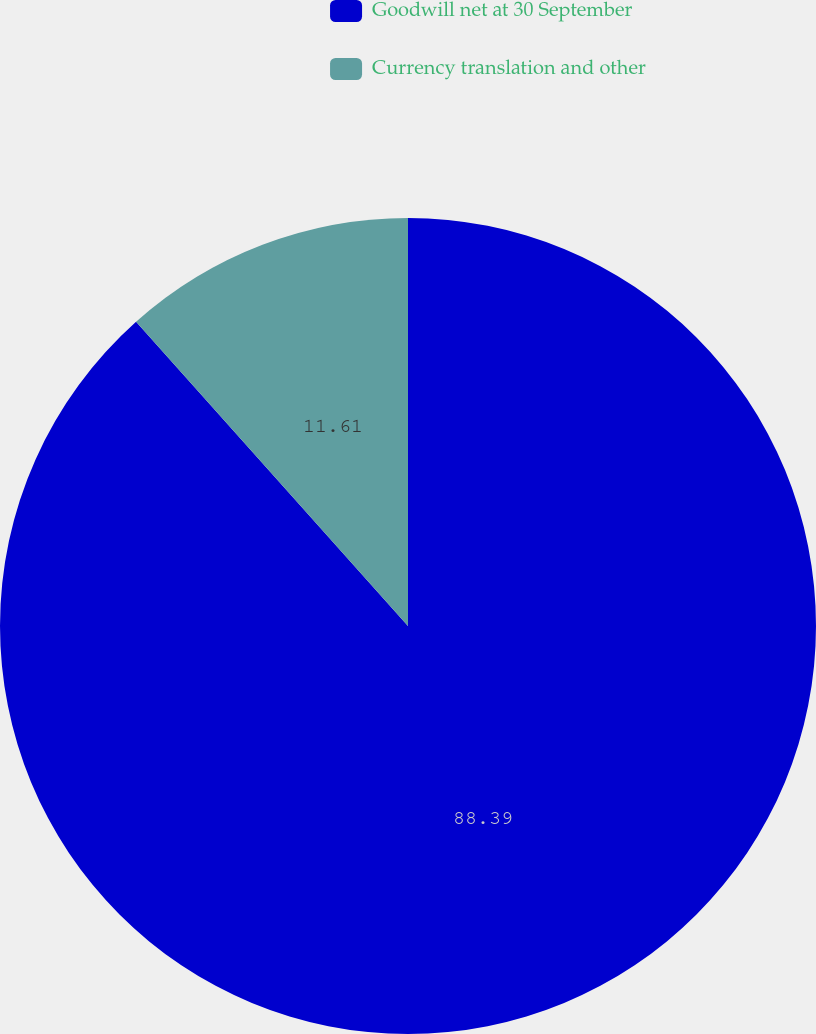Convert chart to OTSL. <chart><loc_0><loc_0><loc_500><loc_500><pie_chart><fcel>Goodwill net at 30 September<fcel>Currency translation and other<nl><fcel>88.39%<fcel>11.61%<nl></chart> 